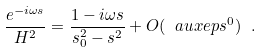Convert formula to latex. <formula><loc_0><loc_0><loc_500><loc_500>\frac { e ^ { - i \omega s } } { H ^ { 2 } } = \frac { 1 - i \omega s } { s _ { 0 } ^ { 2 } - s ^ { 2 } } + O ( \ a u x e p s ^ { 0 } ) \ .</formula> 